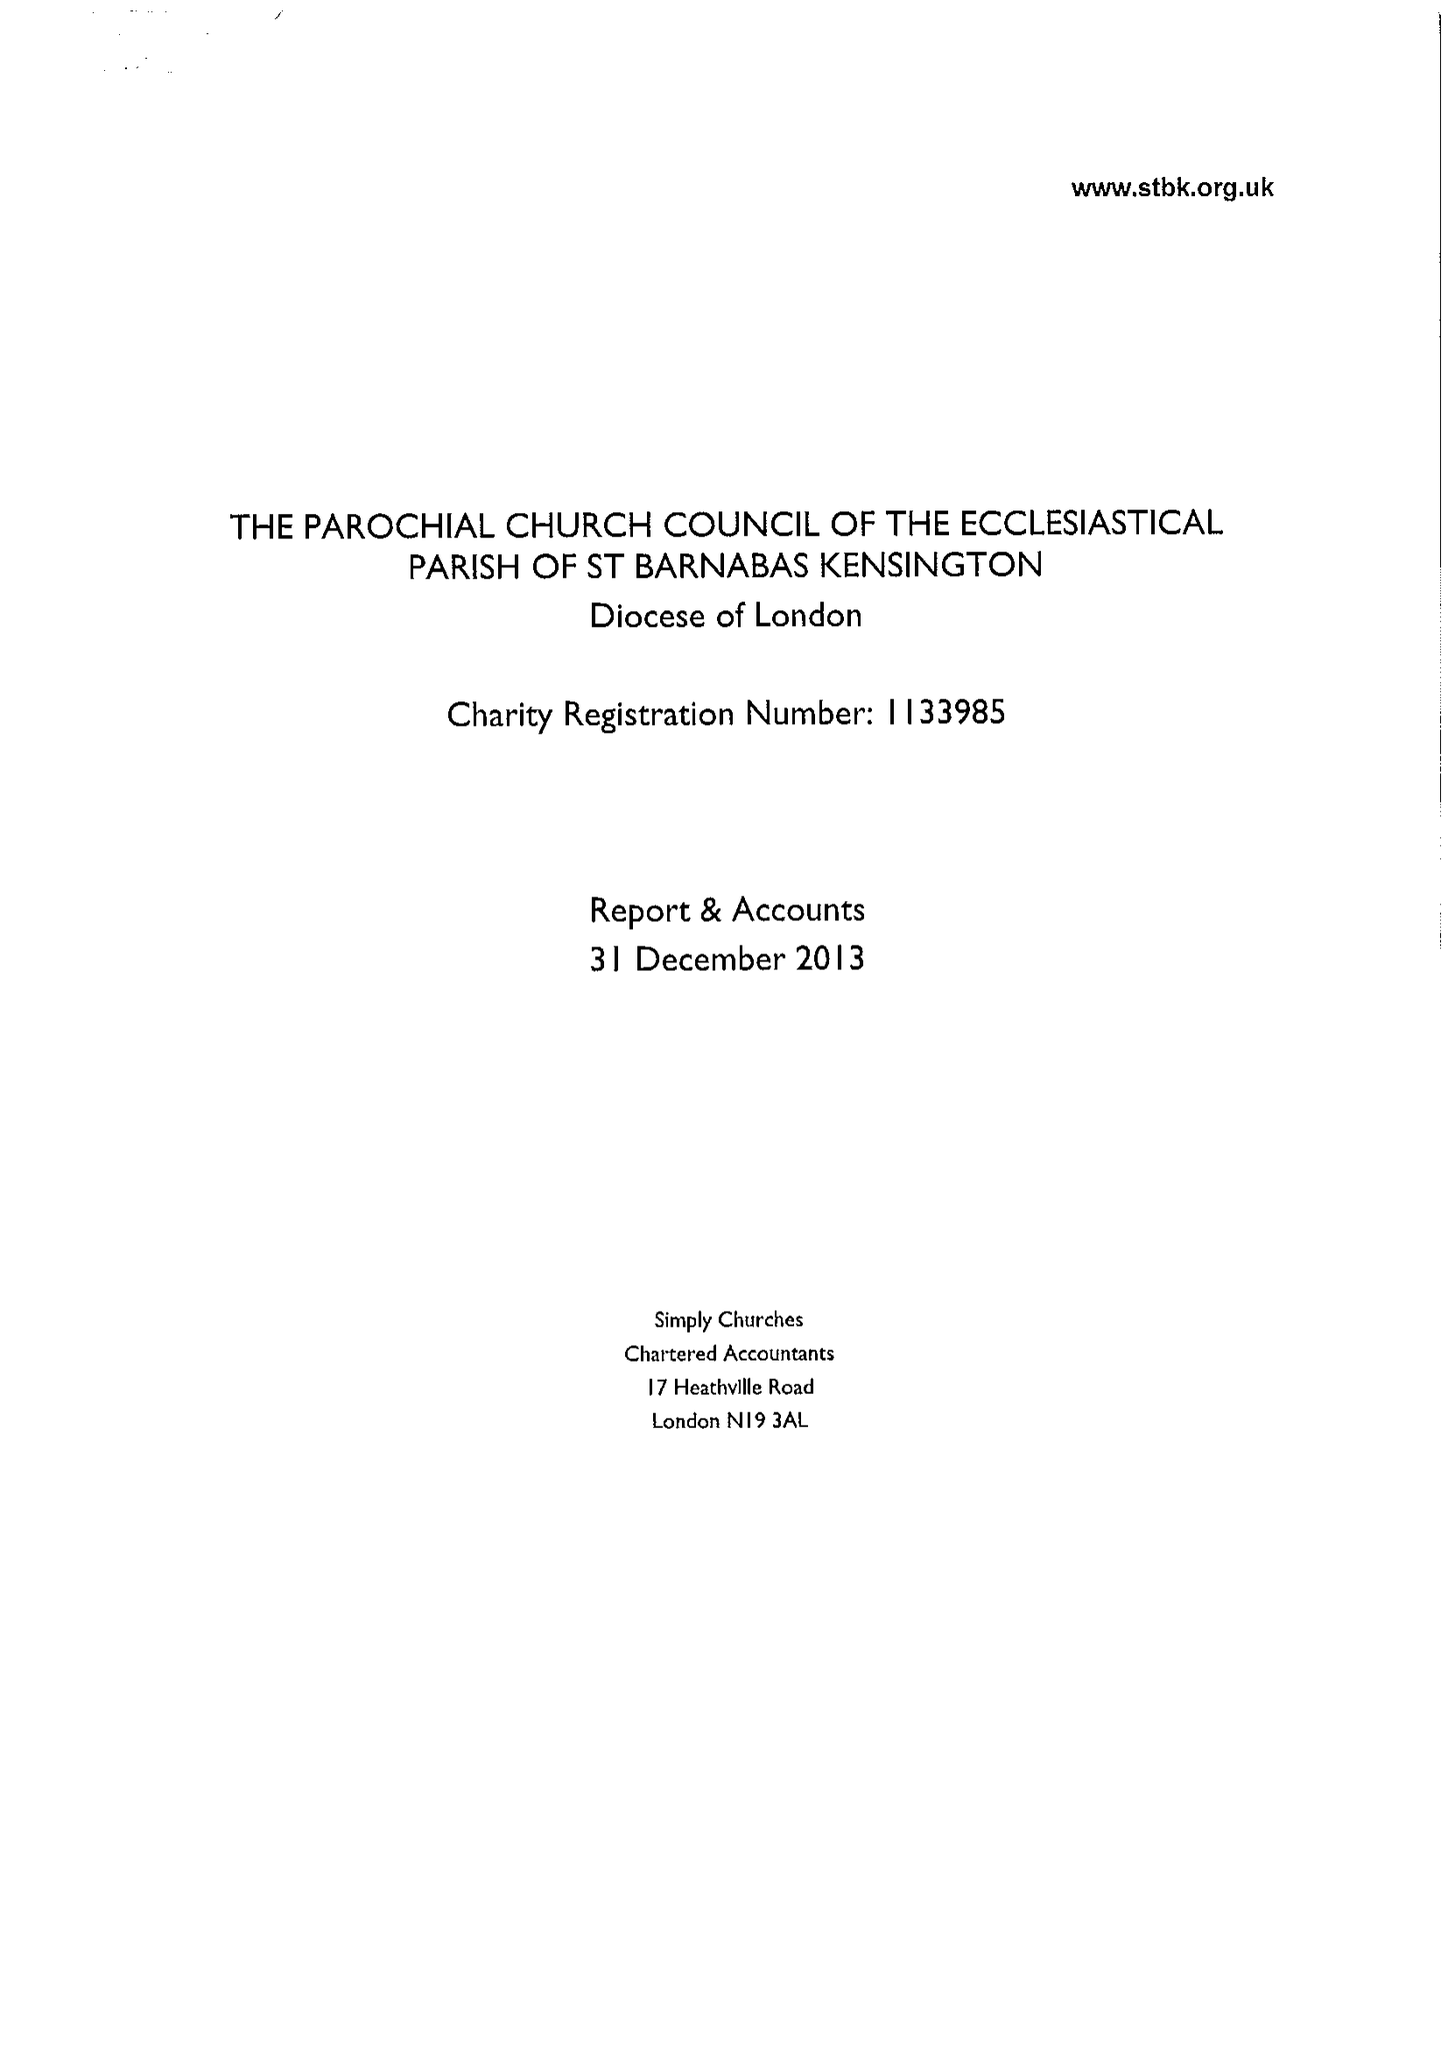What is the value for the charity_name?
Answer the question using a single word or phrase. The Parochial Church Council Of The Ecclesiastical Parish Of St Barnabas Kensington 